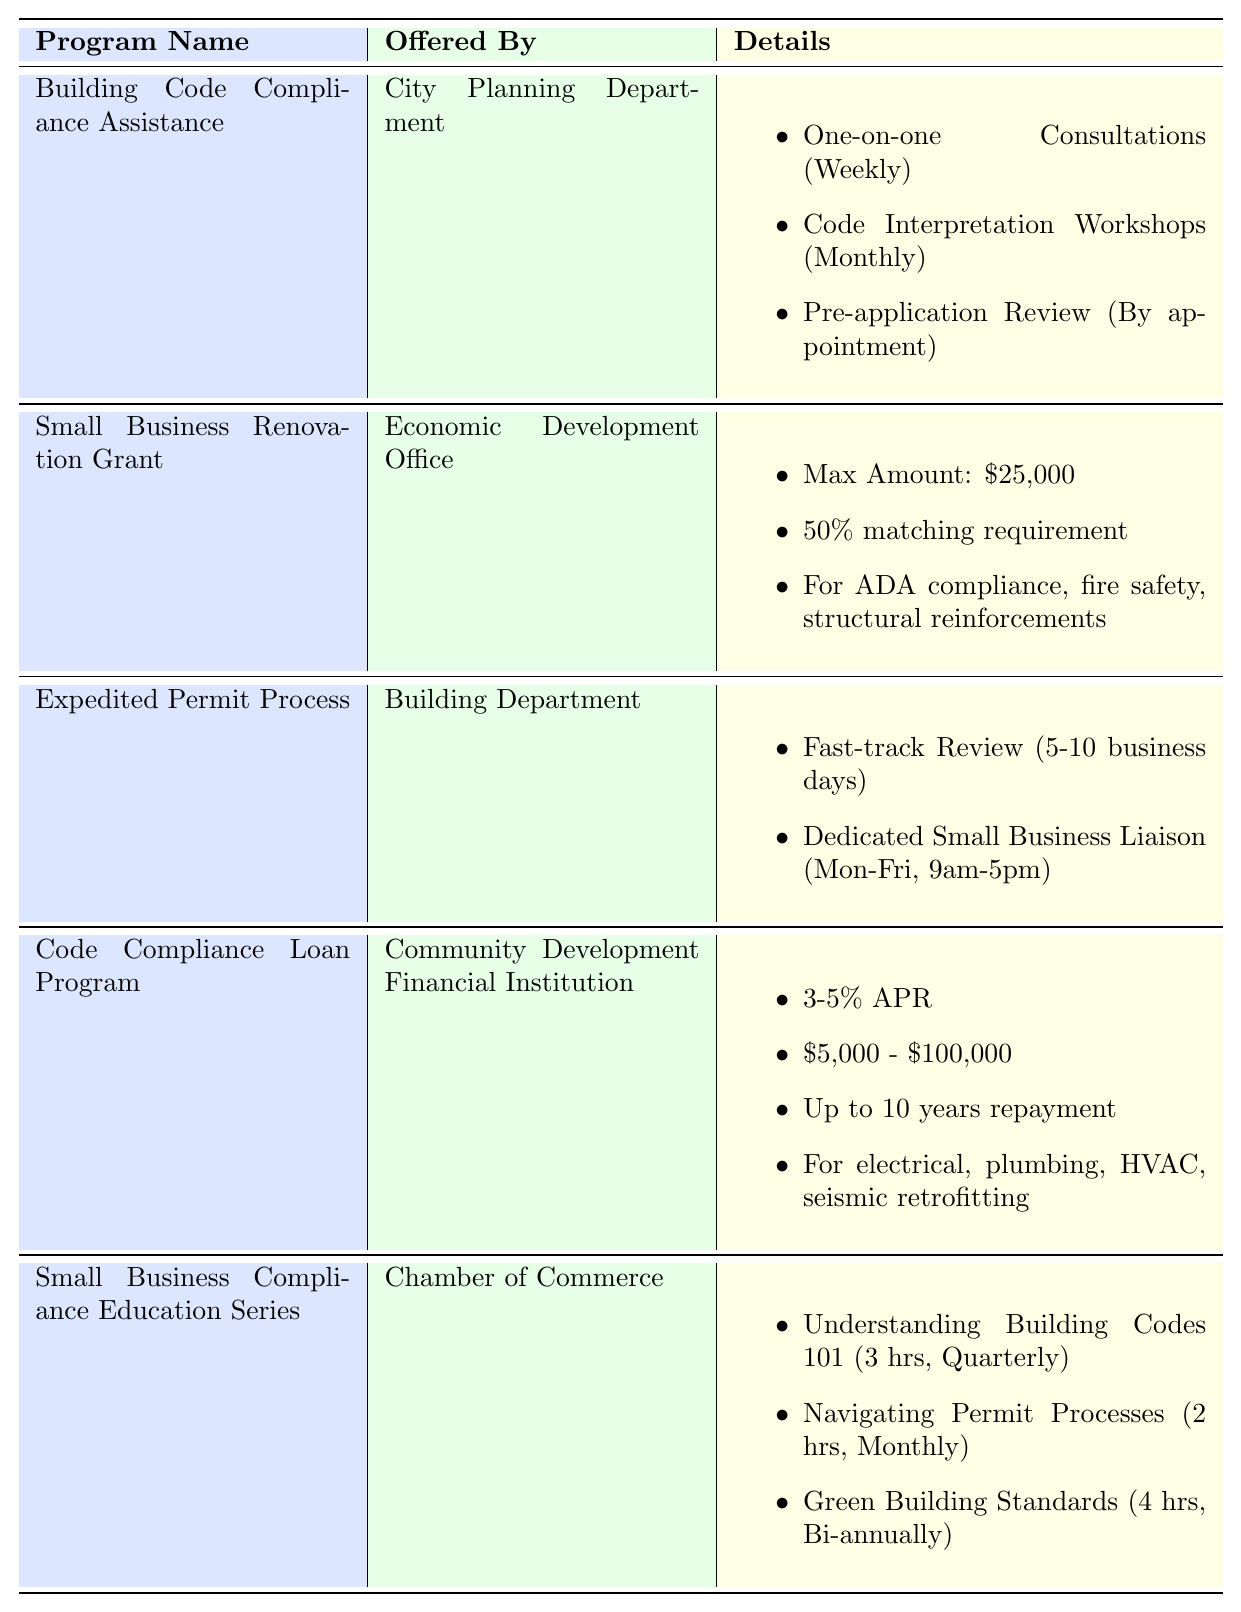What department offers the Building Code Compliance Assistance program? The table lists the "Building Code Compliance Assistance" program and states it is offered by the "City Planning Department."
Answer: City Planning Department How many services are included in the Building Code Compliance Assistance program? Under the "Details" column for this program, there are three listed services: One-on-one Consultations, Code Interpretation Workshops, and Pre-application Review.
Answer: 3 Is the Small Business Renovation Grant available for businesses with fewer than 100 employees? The eligibility criteria for the Small Business Renovation Grant states that it is available to businesses with fewer than 50 employees, hence it is not available for those with 100 employees.
Answer: No What is the maximum loan amount available in the Code Compliance Loan Program? The table states that the maximum loan amount available in this program is between $5,000 and $100,000, specifically mentioning "$100,000" as the upper limit.
Answer: $100,000 How often are Code Interpretation Workshops held? The table lists the frequency of the Code Interpretation Workshops under the Building Code Compliance Assistance program, indicating that they are held monthly.
Answer: Monthly What is the total number of courses offered in the Small Business Compliance Education Series? There are three courses listed under the Course Offerings for the Small Business Compliance Education Series: Understanding Building Codes 101, Navigating Permit Processes, and Green Building Standards for Small Businesses, making a total of three courses.
Answer: 3 If a business applies for the Small Business Renovation Grant and spends $40,000, how much money do they need to provide as their matching requirement? The grant has a matching requirement of 50% of project costs. Therefore, for a $40,000 project, the business would need to provide $20,000 as a matching requirement, calculated as 50% of $40,000.
Answer: $20,000 What is the typical timeframe for the Expedited Permit Process? The table specifies that the typical timeframe for the Fast-track Review in the Expedited Permit Process is 5-10 business days.
Answer: 5-10 business days If a business wants to attend all courses in the Small Business Compliance Education Series within a year, how many hours will they need to commit? The individual course durations are 3 hours, 2 hours, and 4 hours. Calculating the total based on the frequency: 3 hours (quarterly = 4 times/year) + 2 hours (monthly = 12 times/year) + 4 hours (bi-annually = 2 times/year) gives: (3 * 4) + (2 * 12) + (4 * 2) = 12 + 24 + 8 = 44 hours.
Answer: 44 hours Which program requires a repayment period of up to 10 years? The Code Compliance Loan Program states that it has a repayment period of up to 10 years as part of the loan terms.
Answer: Code Compliance Loan Program Does the Expedited Permit Process provide a dedicated small business liaison? Yes, the Expedited Permit Process includes a feature for a Dedicated Small Business Liaison, which is mentioned in the table.
Answer: Yes 